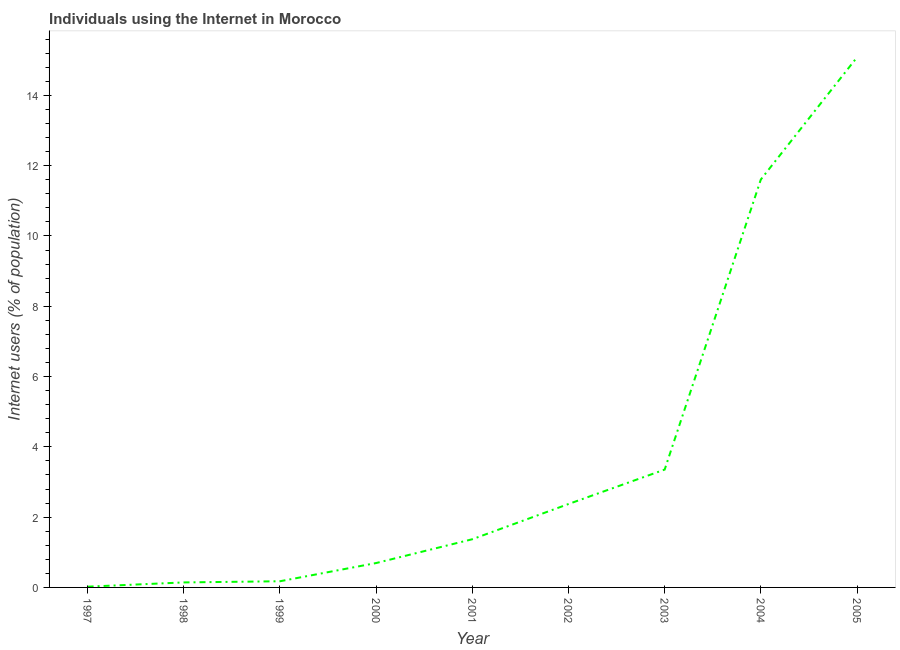What is the number of internet users in 2000?
Provide a short and direct response. 0.69. Across all years, what is the maximum number of internet users?
Offer a terse response. 15.08. Across all years, what is the minimum number of internet users?
Make the answer very short. 0.02. What is the sum of the number of internet users?
Offer a terse response. 34.82. What is the difference between the number of internet users in 1999 and 2005?
Your response must be concise. -14.91. What is the average number of internet users per year?
Your response must be concise. 3.87. What is the median number of internet users?
Keep it short and to the point. 1.37. In how many years, is the number of internet users greater than 5.2 %?
Make the answer very short. 2. What is the ratio of the number of internet users in 1998 to that in 2001?
Your response must be concise. 0.1. Is the number of internet users in 1997 less than that in 2001?
Offer a terse response. Yes. Is the difference between the number of internet users in 1999 and 2003 greater than the difference between any two years?
Offer a very short reply. No. What is the difference between the highest and the second highest number of internet users?
Offer a terse response. 3.48. Is the sum of the number of internet users in 2002 and 2004 greater than the maximum number of internet users across all years?
Provide a succinct answer. No. What is the difference between the highest and the lowest number of internet users?
Give a very brief answer. 15.06. In how many years, is the number of internet users greater than the average number of internet users taken over all years?
Provide a succinct answer. 2. Does the number of internet users monotonically increase over the years?
Provide a succinct answer. Yes. How many years are there in the graph?
Provide a short and direct response. 9. What is the difference between two consecutive major ticks on the Y-axis?
Give a very brief answer. 2. Are the values on the major ticks of Y-axis written in scientific E-notation?
Offer a terse response. No. Does the graph contain grids?
Provide a short and direct response. No. What is the title of the graph?
Make the answer very short. Individuals using the Internet in Morocco. What is the label or title of the Y-axis?
Ensure brevity in your answer.  Internet users (% of population). What is the Internet users (% of population) of 1997?
Make the answer very short. 0.02. What is the Internet users (% of population) of 1998?
Keep it short and to the point. 0.14. What is the Internet users (% of population) in 1999?
Give a very brief answer. 0.18. What is the Internet users (% of population) in 2000?
Ensure brevity in your answer.  0.69. What is the Internet users (% of population) in 2001?
Your answer should be very brief. 1.37. What is the Internet users (% of population) in 2002?
Your response must be concise. 2.37. What is the Internet users (% of population) in 2003?
Make the answer very short. 3.35. What is the Internet users (% of population) of 2004?
Your answer should be very brief. 11.61. What is the Internet users (% of population) of 2005?
Ensure brevity in your answer.  15.08. What is the difference between the Internet users (% of population) in 1997 and 1998?
Keep it short and to the point. -0.12. What is the difference between the Internet users (% of population) in 1997 and 1999?
Your response must be concise. -0.15. What is the difference between the Internet users (% of population) in 1997 and 2000?
Your answer should be compact. -0.67. What is the difference between the Internet users (% of population) in 1997 and 2001?
Offer a terse response. -1.35. What is the difference between the Internet users (% of population) in 1997 and 2002?
Ensure brevity in your answer.  -2.35. What is the difference between the Internet users (% of population) in 1997 and 2003?
Make the answer very short. -3.33. What is the difference between the Internet users (% of population) in 1997 and 2004?
Offer a terse response. -11.59. What is the difference between the Internet users (% of population) in 1997 and 2005?
Make the answer very short. -15.06. What is the difference between the Internet users (% of population) in 1998 and 1999?
Keep it short and to the point. -0.03. What is the difference between the Internet users (% of population) in 1998 and 2000?
Your response must be concise. -0.55. What is the difference between the Internet users (% of population) in 1998 and 2001?
Your response must be concise. -1.23. What is the difference between the Internet users (% of population) in 1998 and 2002?
Provide a short and direct response. -2.23. What is the difference between the Internet users (% of population) in 1998 and 2003?
Provide a short and direct response. -3.21. What is the difference between the Internet users (% of population) in 1998 and 2004?
Your response must be concise. -11.47. What is the difference between the Internet users (% of population) in 1998 and 2005?
Offer a terse response. -14.94. What is the difference between the Internet users (% of population) in 1999 and 2000?
Your answer should be compact. -0.52. What is the difference between the Internet users (% of population) in 1999 and 2001?
Ensure brevity in your answer.  -1.2. What is the difference between the Internet users (% of population) in 1999 and 2002?
Ensure brevity in your answer.  -2.2. What is the difference between the Internet users (% of population) in 1999 and 2003?
Offer a terse response. -3.18. What is the difference between the Internet users (% of population) in 1999 and 2004?
Offer a very short reply. -11.43. What is the difference between the Internet users (% of population) in 1999 and 2005?
Give a very brief answer. -14.91. What is the difference between the Internet users (% of population) in 2000 and 2001?
Provide a short and direct response. -0.68. What is the difference between the Internet users (% of population) in 2000 and 2002?
Provide a short and direct response. -1.68. What is the difference between the Internet users (% of population) in 2000 and 2003?
Offer a terse response. -2.66. What is the difference between the Internet users (% of population) in 2000 and 2004?
Your answer should be very brief. -10.91. What is the difference between the Internet users (% of population) in 2000 and 2005?
Your answer should be compact. -14.39. What is the difference between the Internet users (% of population) in 2001 and 2002?
Ensure brevity in your answer.  -1. What is the difference between the Internet users (% of population) in 2001 and 2003?
Offer a terse response. -1.98. What is the difference between the Internet users (% of population) in 2001 and 2004?
Ensure brevity in your answer.  -10.24. What is the difference between the Internet users (% of population) in 2001 and 2005?
Your answer should be compact. -13.71. What is the difference between the Internet users (% of population) in 2002 and 2003?
Provide a short and direct response. -0.98. What is the difference between the Internet users (% of population) in 2002 and 2004?
Your response must be concise. -9.23. What is the difference between the Internet users (% of population) in 2002 and 2005?
Ensure brevity in your answer.  -12.71. What is the difference between the Internet users (% of population) in 2003 and 2004?
Offer a terse response. -8.25. What is the difference between the Internet users (% of population) in 2003 and 2005?
Give a very brief answer. -11.73. What is the difference between the Internet users (% of population) in 2004 and 2005?
Provide a short and direct response. -3.48. What is the ratio of the Internet users (% of population) in 1997 to that in 1998?
Ensure brevity in your answer.  0.15. What is the ratio of the Internet users (% of population) in 1997 to that in 1999?
Your response must be concise. 0.12. What is the ratio of the Internet users (% of population) in 1997 to that in 2000?
Make the answer very short. 0.03. What is the ratio of the Internet users (% of population) in 1997 to that in 2001?
Provide a short and direct response. 0.02. What is the ratio of the Internet users (% of population) in 1997 to that in 2002?
Your answer should be compact. 0.01. What is the ratio of the Internet users (% of population) in 1997 to that in 2003?
Give a very brief answer. 0.01. What is the ratio of the Internet users (% of population) in 1997 to that in 2004?
Give a very brief answer. 0. What is the ratio of the Internet users (% of population) in 1998 to that in 1999?
Give a very brief answer. 0.81. What is the ratio of the Internet users (% of population) in 1998 to that in 2000?
Offer a terse response. 0.2. What is the ratio of the Internet users (% of population) in 1998 to that in 2001?
Offer a very short reply. 0.1. What is the ratio of the Internet users (% of population) in 1998 to that in 2003?
Your answer should be compact. 0.04. What is the ratio of the Internet users (% of population) in 1998 to that in 2004?
Make the answer very short. 0.01. What is the ratio of the Internet users (% of population) in 1998 to that in 2005?
Provide a succinct answer. 0.01. What is the ratio of the Internet users (% of population) in 1999 to that in 2000?
Give a very brief answer. 0.25. What is the ratio of the Internet users (% of population) in 1999 to that in 2001?
Keep it short and to the point. 0.13. What is the ratio of the Internet users (% of population) in 1999 to that in 2002?
Ensure brevity in your answer.  0.07. What is the ratio of the Internet users (% of population) in 1999 to that in 2003?
Make the answer very short. 0.05. What is the ratio of the Internet users (% of population) in 1999 to that in 2004?
Provide a short and direct response. 0.01. What is the ratio of the Internet users (% of population) in 1999 to that in 2005?
Your answer should be compact. 0.01. What is the ratio of the Internet users (% of population) in 2000 to that in 2001?
Provide a succinct answer. 0.51. What is the ratio of the Internet users (% of population) in 2000 to that in 2002?
Offer a terse response. 0.29. What is the ratio of the Internet users (% of population) in 2000 to that in 2003?
Make the answer very short. 0.21. What is the ratio of the Internet users (% of population) in 2000 to that in 2005?
Offer a terse response. 0.05. What is the ratio of the Internet users (% of population) in 2001 to that in 2002?
Your answer should be very brief. 0.58. What is the ratio of the Internet users (% of population) in 2001 to that in 2003?
Ensure brevity in your answer.  0.41. What is the ratio of the Internet users (% of population) in 2001 to that in 2004?
Give a very brief answer. 0.12. What is the ratio of the Internet users (% of population) in 2001 to that in 2005?
Your answer should be very brief. 0.09. What is the ratio of the Internet users (% of population) in 2002 to that in 2003?
Your response must be concise. 0.71. What is the ratio of the Internet users (% of population) in 2002 to that in 2004?
Offer a terse response. 0.2. What is the ratio of the Internet users (% of population) in 2002 to that in 2005?
Your response must be concise. 0.16. What is the ratio of the Internet users (% of population) in 2003 to that in 2004?
Your answer should be compact. 0.29. What is the ratio of the Internet users (% of population) in 2003 to that in 2005?
Offer a terse response. 0.22. What is the ratio of the Internet users (% of population) in 2004 to that in 2005?
Offer a terse response. 0.77. 